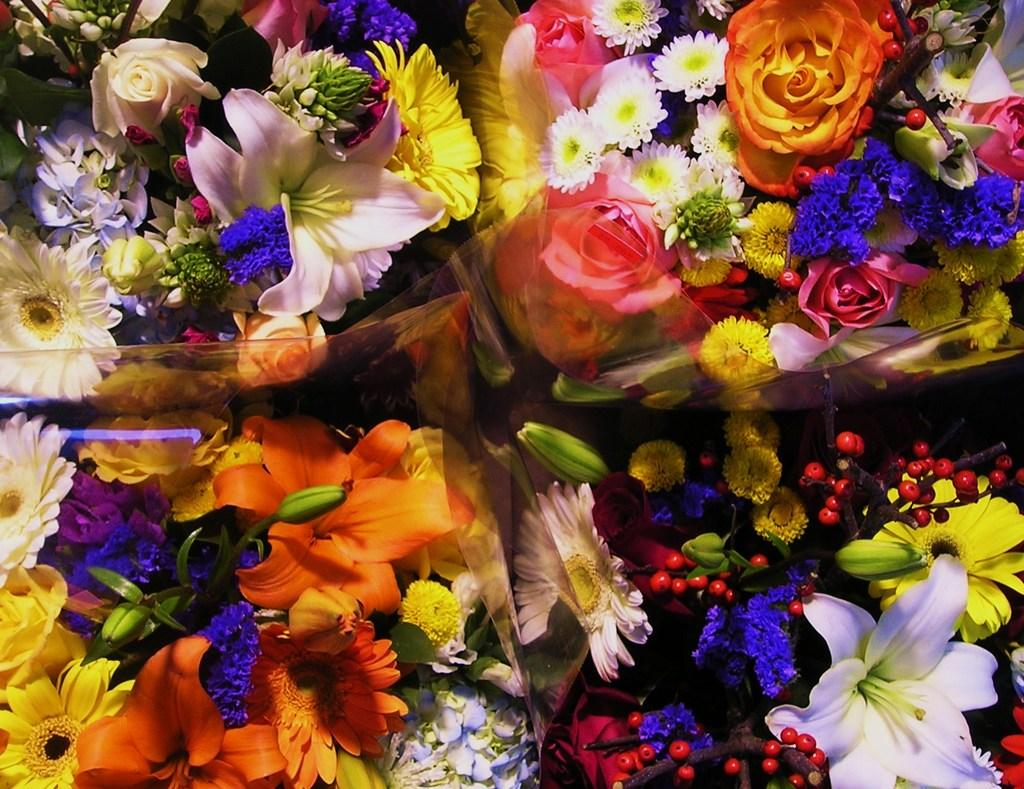What type of plants can be seen in the image? There are flowers in the image. Can you describe the stage of growth for some of the plants? Yes, there are buds in the image, which are flowers in the early stages of development. What flavor of quilt can be seen in the image? There is no quilt present in the image, so it is not possible to determine its flavor. 